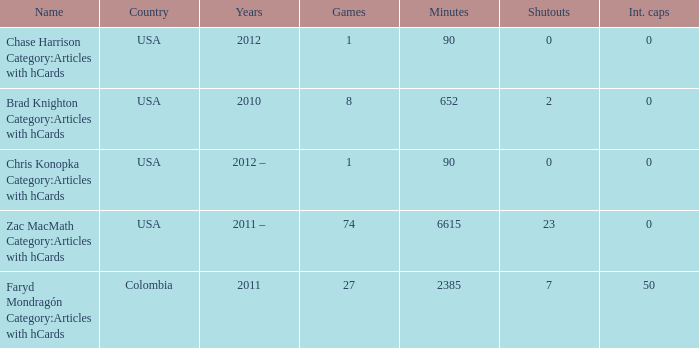When 2010 is the year what is the game? 8.0. 